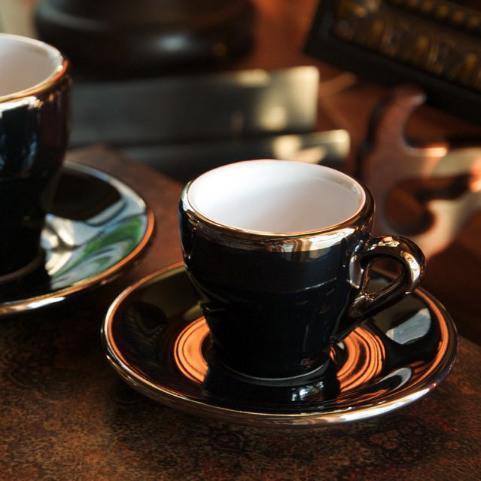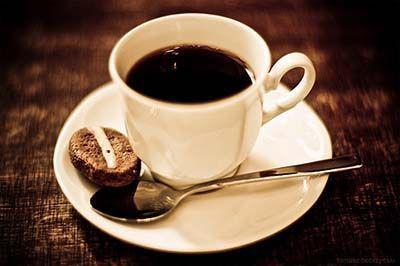The first image is the image on the left, the second image is the image on the right. Analyze the images presented: Is the assertion "Liquid is being poured into a cup in the left image of the pair." valid? Answer yes or no. No. The first image is the image on the left, the second image is the image on the right. For the images displayed, is the sentence "There are coffee beans in exactly one of the images." factually correct? Answer yes or no. No. 